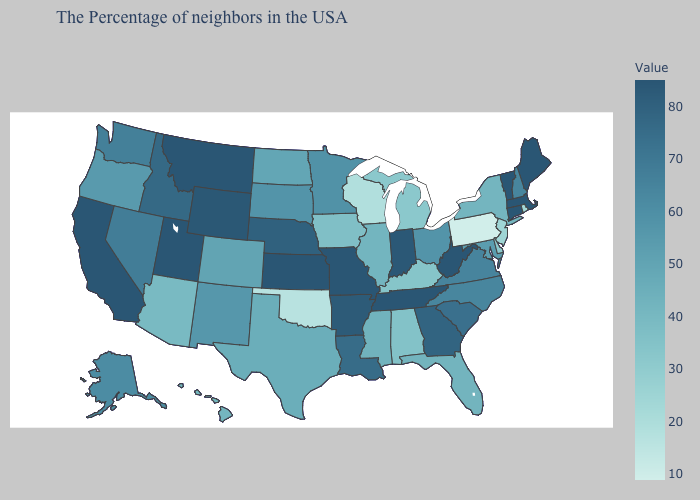Does West Virginia have a lower value than Arizona?
Short answer required. No. Does California have the highest value in the West?
Answer briefly. Yes. Does Oklahoma have the lowest value in the South?
Short answer required. Yes. 